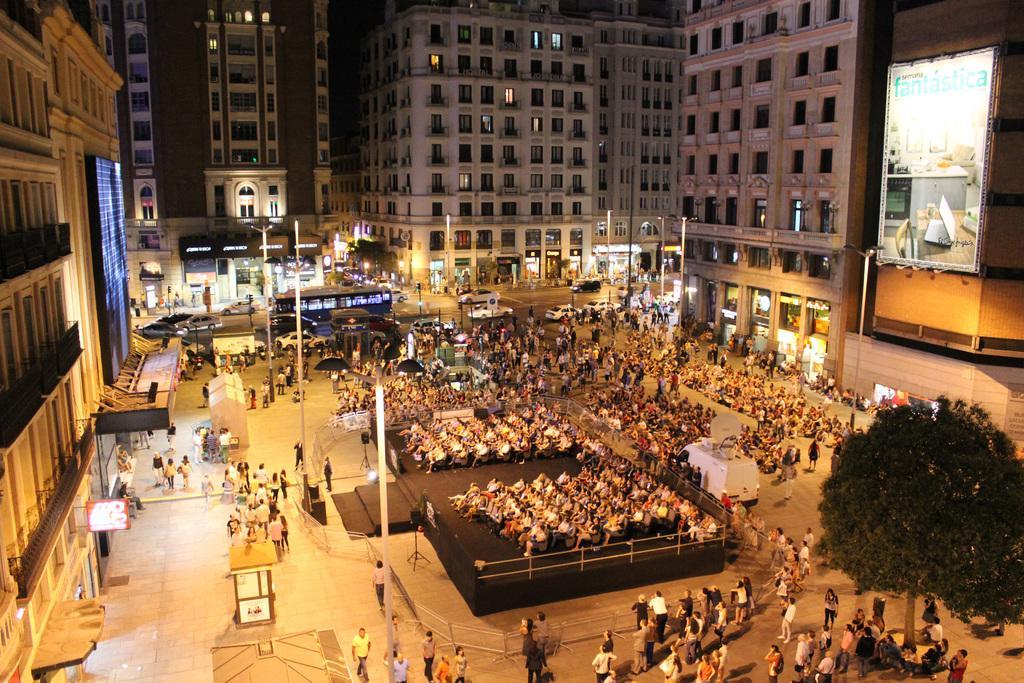Can you describe this image briefly? In this image I see number of people and I see the vehicles on the road and I see the poles and I see number of buildings and I see a tree over here. 